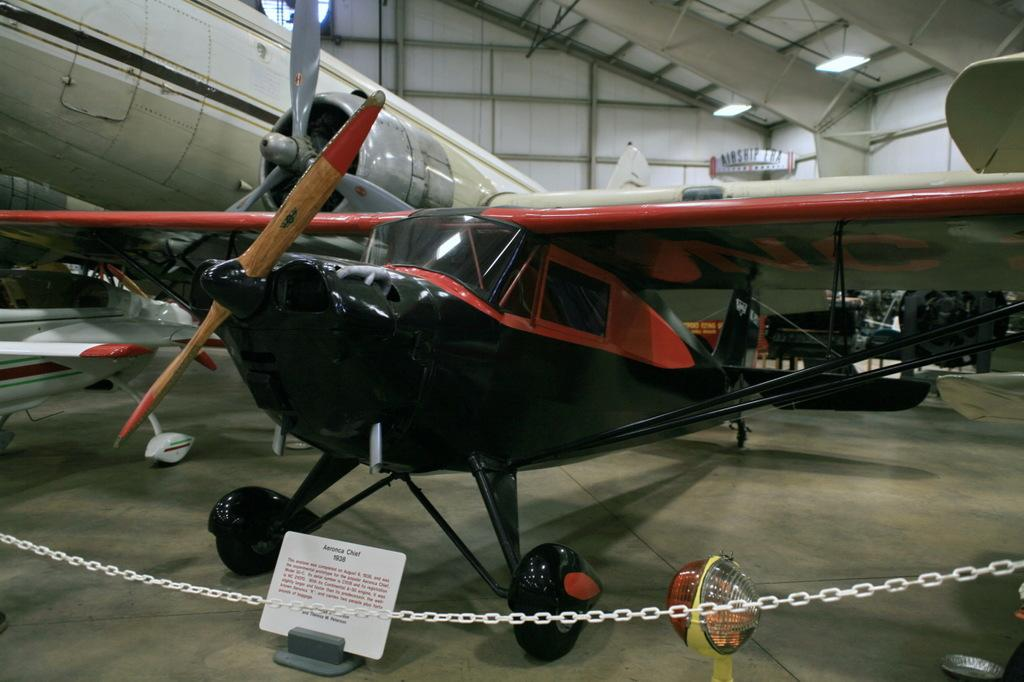What is the main subject of the image? The main subject of the image is aircraft. What else can be seen in the image besides the aircraft? There is a board with text, a chain barrier, and lights in the image. How many sheep are visible in the image? There are no sheep present in the image. What type of leather is used to make the aircraft in the image? The image does not provide information about the materials used to make the aircraft, and there is no leather visible in the image. 